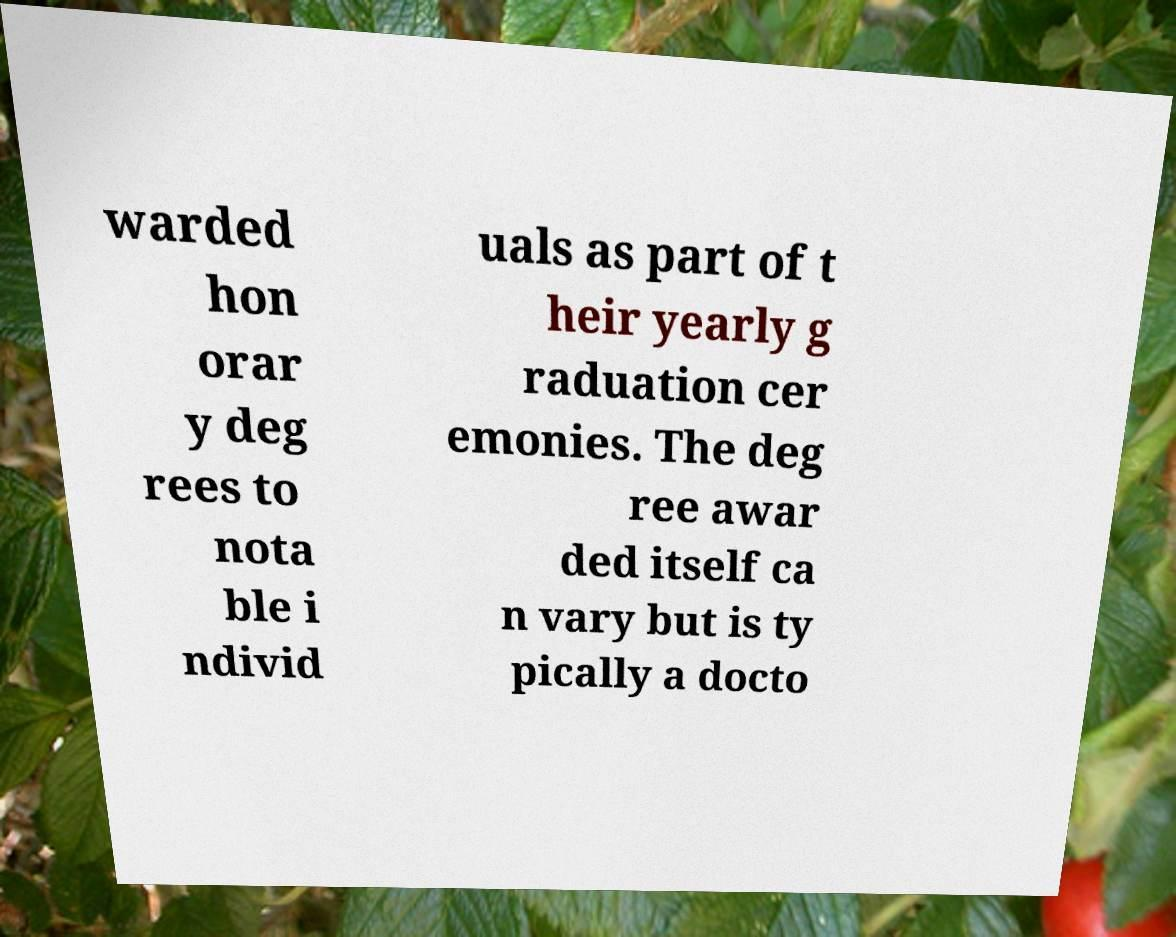Can you read and provide the text displayed in the image?This photo seems to have some interesting text. Can you extract and type it out for me? warded hon orar y deg rees to nota ble i ndivid uals as part of t heir yearly g raduation cer emonies. The deg ree awar ded itself ca n vary but is ty pically a docto 